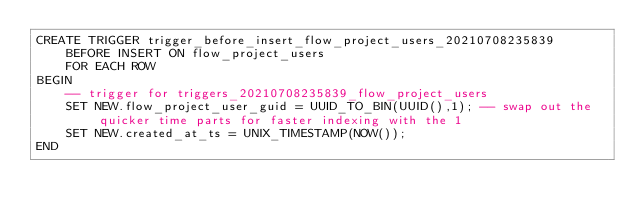<code> <loc_0><loc_0><loc_500><loc_500><_SQL_>CREATE TRIGGER trigger_before_insert_flow_project_users_20210708235839
    BEFORE INSERT ON flow_project_users
    FOR EACH ROW
BEGIN
    -- trigger for triggers_20210708235839_flow_project_users
    SET NEW.flow_project_user_guid = UUID_TO_BIN(UUID(),1); -- swap out the quicker time parts for faster indexing with the 1
    SET NEW.created_at_ts = UNIX_TIMESTAMP(NOW());
END</code> 